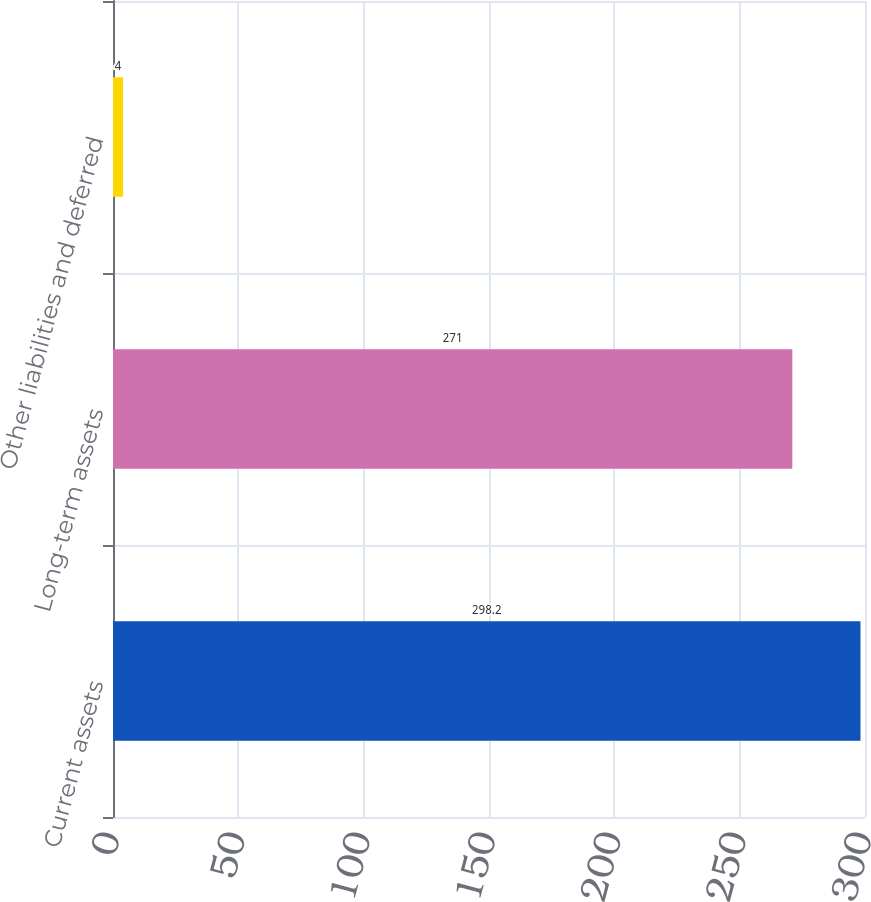Convert chart. <chart><loc_0><loc_0><loc_500><loc_500><bar_chart><fcel>Current assets<fcel>Long-term assets<fcel>Other liabilities and deferred<nl><fcel>298.2<fcel>271<fcel>4<nl></chart> 